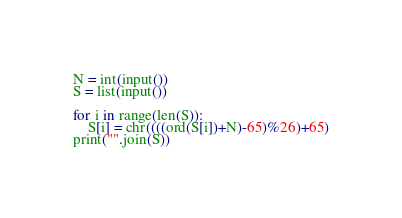Convert code to text. <code><loc_0><loc_0><loc_500><loc_500><_Python_>N = int(input())
S = list(input())

for i in range(len(S)):
    S[i] = chr((((ord(S[i])+N)-65)%26)+65)
print("".join(S))</code> 